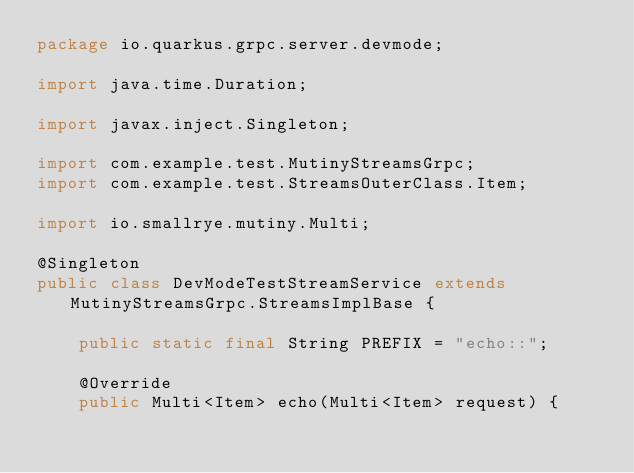<code> <loc_0><loc_0><loc_500><loc_500><_Java_>package io.quarkus.grpc.server.devmode;

import java.time.Duration;

import javax.inject.Singleton;

import com.example.test.MutinyStreamsGrpc;
import com.example.test.StreamsOuterClass.Item;

import io.smallrye.mutiny.Multi;

@Singleton
public class DevModeTestStreamService extends MutinyStreamsGrpc.StreamsImplBase {

    public static final String PREFIX = "echo::";

    @Override
    public Multi<Item> echo(Multi<Item> request) {</code> 